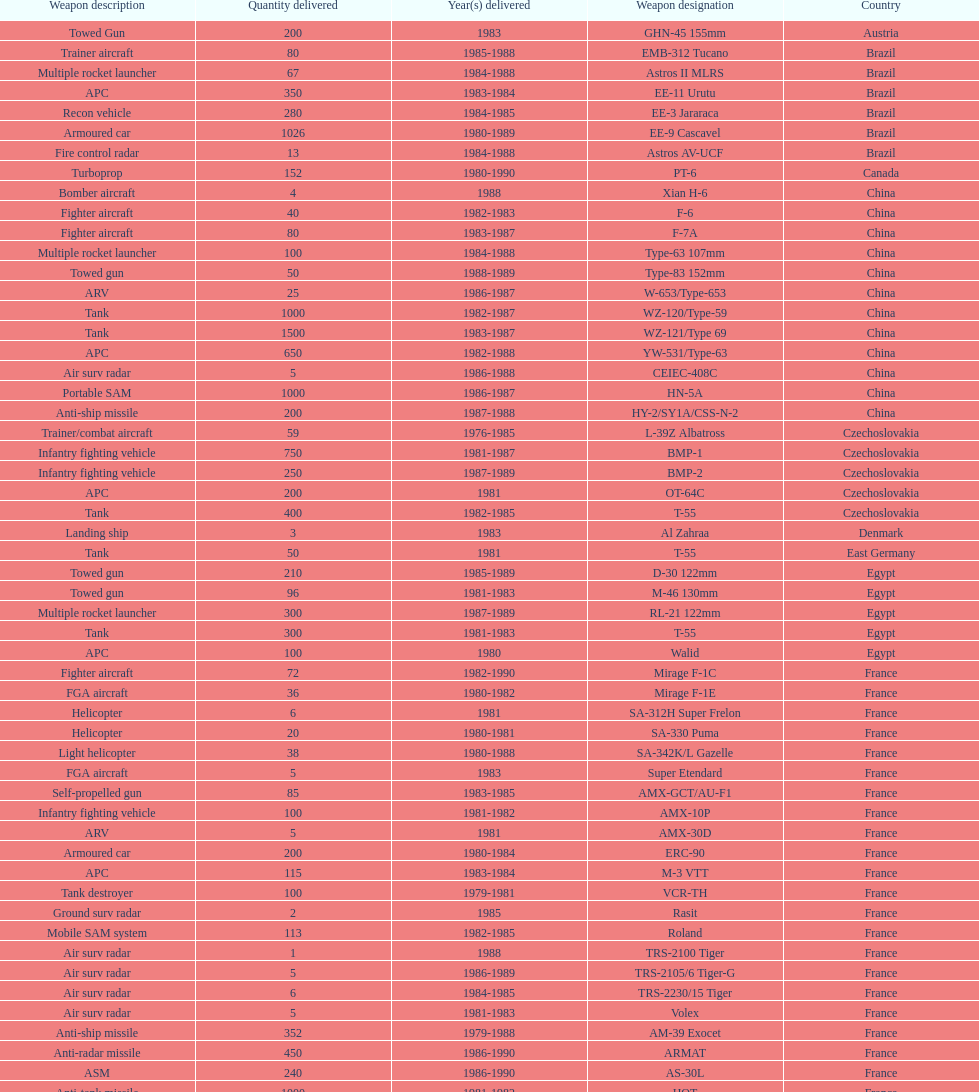According to this list, how many countries sold weapons to iraq? 21. 